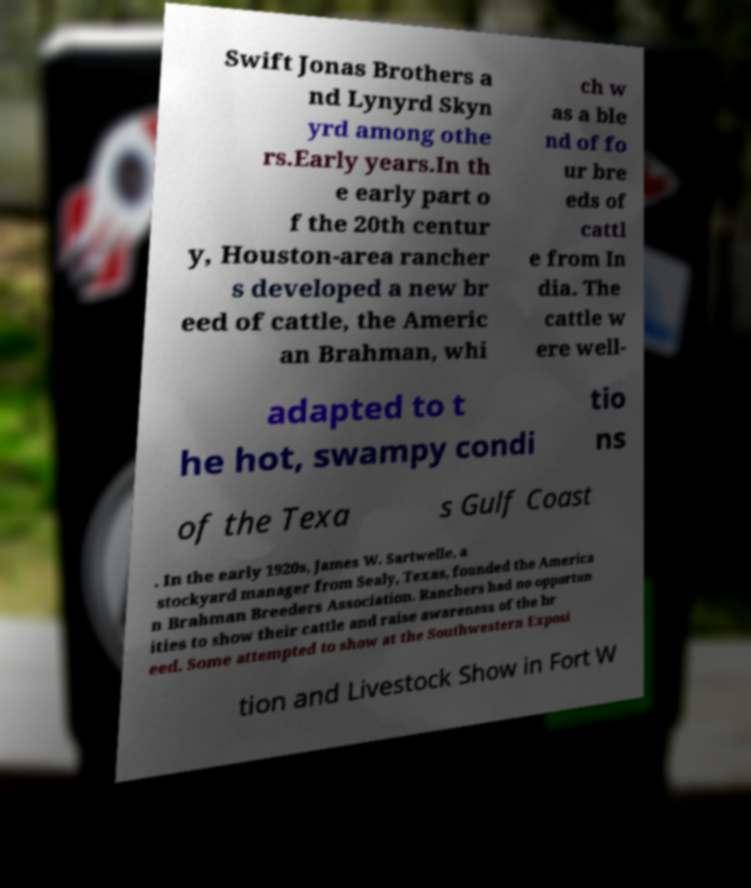Please identify and transcribe the text found in this image. Swift Jonas Brothers a nd Lynyrd Skyn yrd among othe rs.Early years.In th e early part o f the 20th centur y, Houston-area rancher s developed a new br eed of cattle, the Americ an Brahman, whi ch w as a ble nd of fo ur bre eds of cattl e from In dia. The cattle w ere well- adapted to t he hot, swampy condi tio ns of the Texa s Gulf Coast . In the early 1920s, James W. Sartwelle, a stockyard manager from Sealy, Texas, founded the America n Brahman Breeders Association. Ranchers had no opportun ities to show their cattle and raise awareness of the br eed. Some attempted to show at the Southwestern Exposi tion and Livestock Show in Fort W 